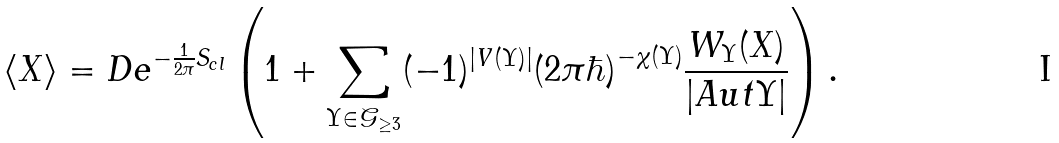<formula> <loc_0><loc_0><loc_500><loc_500>\langle X \rangle = D e ^ { - \frac { 1 } { 2 \pi } S _ { c l } } \left ( 1 + \sum _ { \Upsilon \in \mathcal { G } _ { \geq 3 } } ( - 1 ) ^ { | V ( \Upsilon ) | } ( 2 \pi \hbar { ) } ^ { - \chi ( \Upsilon ) } \frac { W _ { \Upsilon } ( X ) } { | A u t \Upsilon | } \right ) .</formula> 